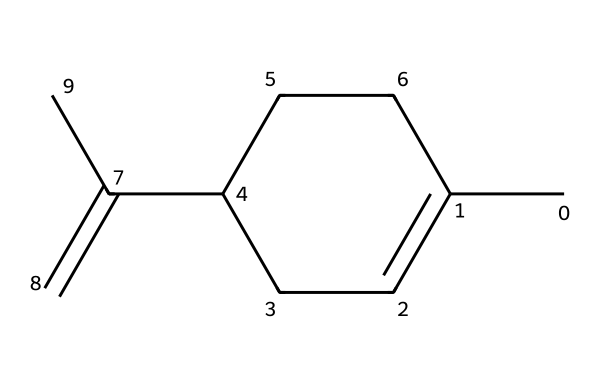What is the molecular formula of limonene? By analyzing the structure through the SMILES representation, we count the carbon (C) and hydrogen (H) atoms. The structure has 10 carbon atoms and 16 hydrogen atoms, leading to the molecular formula C10H16.
Answer: C10H16 How many double bonds are present in limonene's structure? By examining the structure, we can see that there is one C=C double bond located between the C atoms specified in the SMILES. Therefore, the total number of double bonds is one.
Answer: one What type of isomerism is exhibited by limonene? Limonene exhibits geometric isomerism, specifically cis-trans isomerism, due to the presence of a double bond (C=C) that allows for different spatial arrangements of its substituents.
Answer: geometric isomerism What is the relationship between the geometric isomers of limonene? The geometric isomers of limonene are related as they are different spatial arrangements around the double bond, affecting their physical properties, but they have the same molecular formula and can interconvert under certain conditions.
Answer: stereoisomers What functional groups are present in limonene? Limonene primarily contains a carbon-carbon double bond (alkene); it does not have other common functional groups like alcohols or carboxylic acids within its structure.
Answer: alkene How many rings are in the structure of limonene? In the given structure from the SMILES, there is one cyclohexane ring present, which can be identified within the counting of the carbon atoms and the presence of single bonds forming a cycle.
Answer: one 